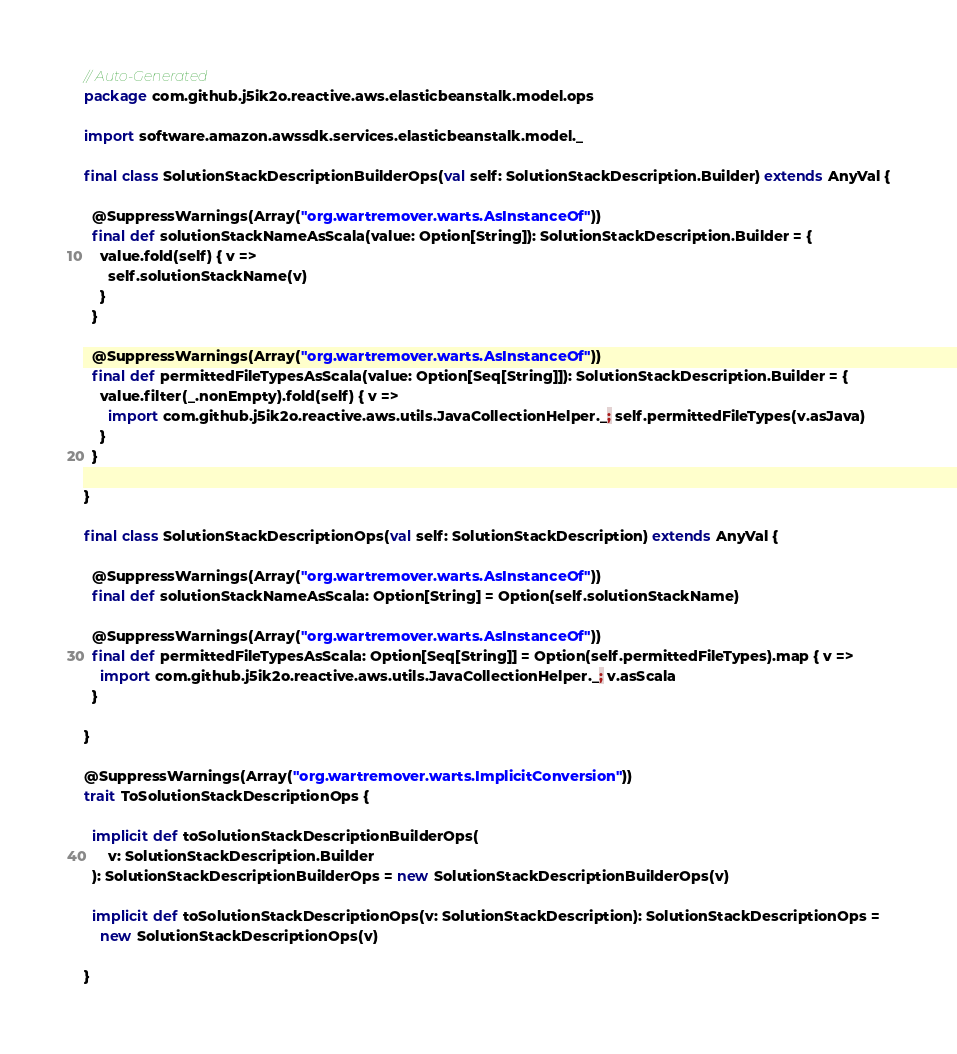<code> <loc_0><loc_0><loc_500><loc_500><_Scala_>// Auto-Generated
package com.github.j5ik2o.reactive.aws.elasticbeanstalk.model.ops

import software.amazon.awssdk.services.elasticbeanstalk.model._

final class SolutionStackDescriptionBuilderOps(val self: SolutionStackDescription.Builder) extends AnyVal {

  @SuppressWarnings(Array("org.wartremover.warts.AsInstanceOf"))
  final def solutionStackNameAsScala(value: Option[String]): SolutionStackDescription.Builder = {
    value.fold(self) { v =>
      self.solutionStackName(v)
    }
  }

  @SuppressWarnings(Array("org.wartremover.warts.AsInstanceOf"))
  final def permittedFileTypesAsScala(value: Option[Seq[String]]): SolutionStackDescription.Builder = {
    value.filter(_.nonEmpty).fold(self) { v =>
      import com.github.j5ik2o.reactive.aws.utils.JavaCollectionHelper._; self.permittedFileTypes(v.asJava)
    }
  }

}

final class SolutionStackDescriptionOps(val self: SolutionStackDescription) extends AnyVal {

  @SuppressWarnings(Array("org.wartremover.warts.AsInstanceOf"))
  final def solutionStackNameAsScala: Option[String] = Option(self.solutionStackName)

  @SuppressWarnings(Array("org.wartremover.warts.AsInstanceOf"))
  final def permittedFileTypesAsScala: Option[Seq[String]] = Option(self.permittedFileTypes).map { v =>
    import com.github.j5ik2o.reactive.aws.utils.JavaCollectionHelper._; v.asScala
  }

}

@SuppressWarnings(Array("org.wartremover.warts.ImplicitConversion"))
trait ToSolutionStackDescriptionOps {

  implicit def toSolutionStackDescriptionBuilderOps(
      v: SolutionStackDescription.Builder
  ): SolutionStackDescriptionBuilderOps = new SolutionStackDescriptionBuilderOps(v)

  implicit def toSolutionStackDescriptionOps(v: SolutionStackDescription): SolutionStackDescriptionOps =
    new SolutionStackDescriptionOps(v)

}
</code> 